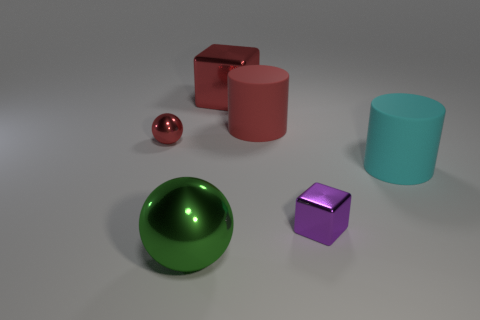Add 4 big red metallic objects. How many objects exist? 10 Subtract all balls. How many objects are left? 4 Add 1 tiny green cylinders. How many tiny green cylinders exist? 1 Subtract 1 red cubes. How many objects are left? 5 Subtract all gray shiny blocks. Subtract all red matte things. How many objects are left? 5 Add 4 red shiny cubes. How many red shiny cubes are left? 5 